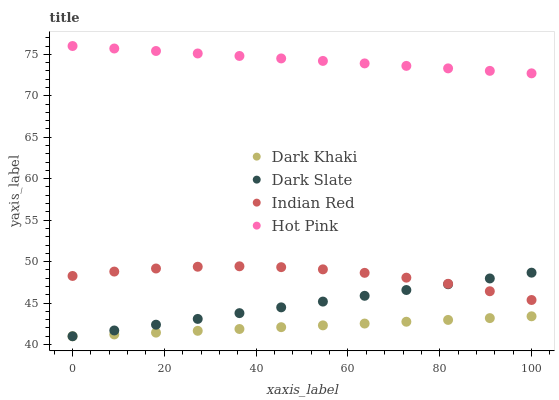Does Dark Khaki have the minimum area under the curve?
Answer yes or no. Yes. Does Hot Pink have the maximum area under the curve?
Answer yes or no. Yes. Does Dark Slate have the minimum area under the curve?
Answer yes or no. No. Does Dark Slate have the maximum area under the curve?
Answer yes or no. No. Is Dark Khaki the smoothest?
Answer yes or no. Yes. Is Indian Red the roughest?
Answer yes or no. Yes. Is Dark Slate the smoothest?
Answer yes or no. No. Is Dark Slate the roughest?
Answer yes or no. No. Does Dark Khaki have the lowest value?
Answer yes or no. Yes. Does Hot Pink have the lowest value?
Answer yes or no. No. Does Hot Pink have the highest value?
Answer yes or no. Yes. Does Dark Slate have the highest value?
Answer yes or no. No. Is Dark Khaki less than Indian Red?
Answer yes or no. Yes. Is Indian Red greater than Dark Khaki?
Answer yes or no. Yes. Does Dark Slate intersect Indian Red?
Answer yes or no. Yes. Is Dark Slate less than Indian Red?
Answer yes or no. No. Is Dark Slate greater than Indian Red?
Answer yes or no. No. Does Dark Khaki intersect Indian Red?
Answer yes or no. No. 